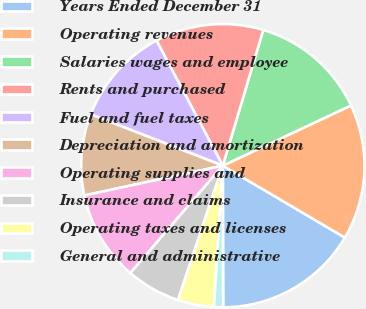<chart> <loc_0><loc_0><loc_500><loc_500><pie_chart><fcel>Years Ended December 31<fcel>Operating revenues<fcel>Salaries wages and employee<fcel>Rents and purchased<fcel>Fuel and fuel taxes<fcel>Depreciation and amortization<fcel>Operating supplies and<fcel>Insurance and claims<fcel>Operating taxes and licenses<fcel>General and administrative<nl><fcel>16.49%<fcel>15.46%<fcel>13.4%<fcel>12.37%<fcel>11.34%<fcel>9.28%<fcel>10.31%<fcel>6.19%<fcel>4.13%<fcel>1.03%<nl></chart> 